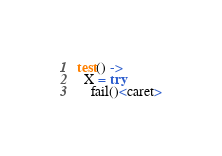<code> <loc_0><loc_0><loc_500><loc_500><_Erlang_>test() ->
  X = try
    fail()<caret></code> 